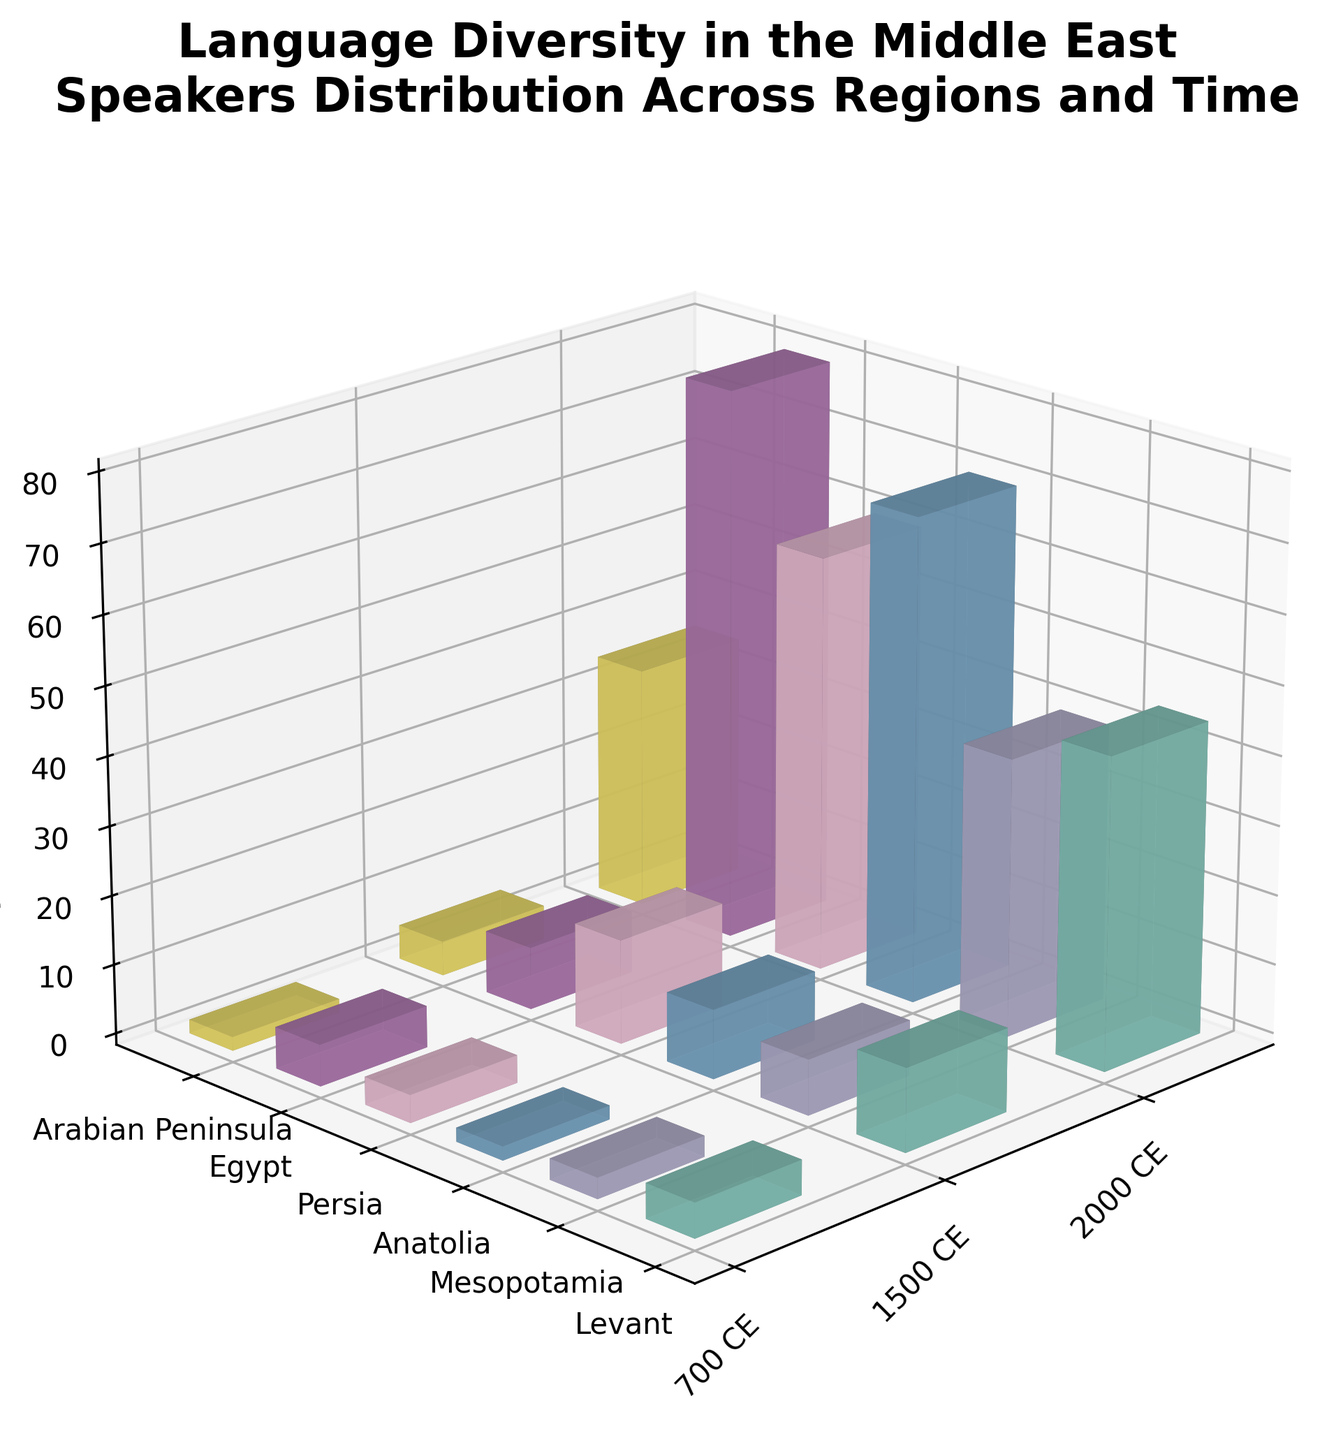What is the title of the figure? The title of the figure is typically placed at the top of the plot and is meant to provide a summary of what the figure is about. In this case, this information is directly available in the figure's title text.
Answer: Language Diversity in the Middle East: Speakers Distribution Across Regions and Time What are the axes labels? Axes labels help in identifying what each axis represents. In this figure, you can visually read the labels on the x, y, and z axes.
Answer: Regions (Y-axis), Time Periods (X-axis), Speakers (millions) (Z-axis) Which region had the highest number of speakers in 700 CE? Look at the x-axis for the 700 CE time period, then compare the height of the bars across different regions to identify the tallest bar.
Answer: Egypt In which region did Turkish become the dominant language by 2000 CE? Locate the 2000 CE time period on the x-axis, then identify the region on the y-axis where the Turkish bar is the tallest.
Answer: Anatolia How did the number of Arabic speakers in the Levant change from 700 CE to 2000 CE? First, find the height of the Arabic bar for the Levant in 700 CE. Then, do the same for 2000 CE. Subtract the 700 CE value from the 2000 CE value to find the change.
Answer: Increased by 40 million Which language had the most significant increase in speakers in Persia from 700 CE to 2000 CE? Compare the height of the bars for each language in Persia between 700 CE and 2000 CE to determine which had the largest increase.
Answer: Persian How many different time periods are represented in the plot? The x-axis represents different time periods. Count the distinct labels present.
Answer: Three Between which consecutive time periods did Arabic speakers in Mesopotamia increase the most? Compare the height of the Arabic bars between each consecutive time period on the x-axis for the Mesopotamia region.
Answer: 1500 CE to 2000 CE What was the number of Old Arabic speakers in the Arabian Peninsula during 700 CE? Find the bar that represents Old Arabic in the Arabian Peninsula for the 700 CE period and read off the height.
Answer: 2 million Which region saw the highest growth in Arabic speakers from 1500 CE to 2000 CE? Compare the growth of Arabic speakers by finding the change in bar height for each region between 1500 CE and 2000 CE.
Answer: Egypt 